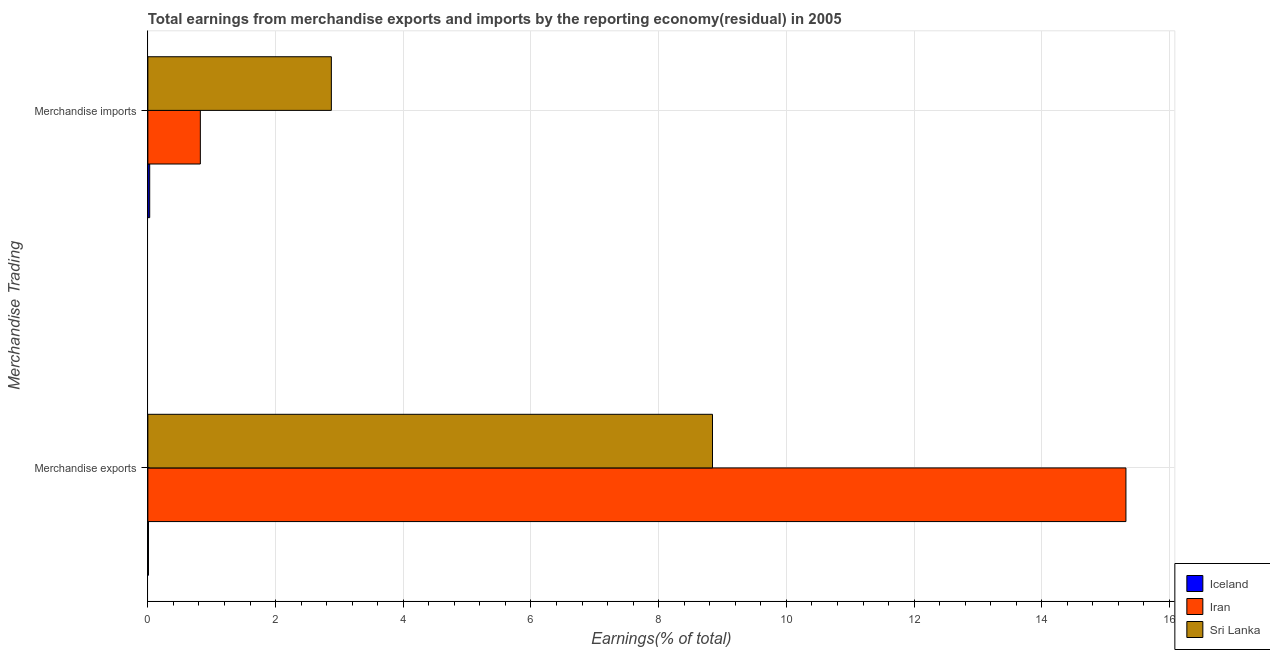How many different coloured bars are there?
Offer a very short reply. 3. How many groups of bars are there?
Your answer should be compact. 2. Are the number of bars on each tick of the Y-axis equal?
Your response must be concise. Yes. What is the earnings from merchandise exports in Iceland?
Offer a very short reply. 0.01. Across all countries, what is the maximum earnings from merchandise exports?
Your answer should be compact. 15.32. Across all countries, what is the minimum earnings from merchandise imports?
Your response must be concise. 0.03. In which country was the earnings from merchandise exports maximum?
Provide a succinct answer. Iran. In which country was the earnings from merchandise imports minimum?
Your response must be concise. Iceland. What is the total earnings from merchandise exports in the graph?
Provide a succinct answer. 24.17. What is the difference between the earnings from merchandise imports in Sri Lanka and that in Iceland?
Your response must be concise. 2.85. What is the difference between the earnings from merchandise imports in Iran and the earnings from merchandise exports in Iceland?
Ensure brevity in your answer.  0.81. What is the average earnings from merchandise exports per country?
Your answer should be very brief. 8.06. What is the difference between the earnings from merchandise imports and earnings from merchandise exports in Sri Lanka?
Offer a very short reply. -5.97. What is the ratio of the earnings from merchandise imports in Iran to that in Iceland?
Offer a very short reply. 28.67. In how many countries, is the earnings from merchandise exports greater than the average earnings from merchandise exports taken over all countries?
Provide a short and direct response. 2. What does the 1st bar from the bottom in Merchandise exports represents?
Keep it short and to the point. Iceland. Are all the bars in the graph horizontal?
Ensure brevity in your answer.  Yes. How many countries are there in the graph?
Offer a terse response. 3. What is the difference between two consecutive major ticks on the X-axis?
Offer a very short reply. 2. Are the values on the major ticks of X-axis written in scientific E-notation?
Your response must be concise. No. Does the graph contain any zero values?
Provide a succinct answer. No. Where does the legend appear in the graph?
Make the answer very short. Bottom right. How many legend labels are there?
Your answer should be compact. 3. What is the title of the graph?
Offer a very short reply. Total earnings from merchandise exports and imports by the reporting economy(residual) in 2005. Does "Latin America(developing only)" appear as one of the legend labels in the graph?
Offer a terse response. No. What is the label or title of the X-axis?
Offer a very short reply. Earnings(% of total). What is the label or title of the Y-axis?
Your answer should be compact. Merchandise Trading. What is the Earnings(% of total) in Iceland in Merchandise exports?
Provide a succinct answer. 0.01. What is the Earnings(% of total) of Iran in Merchandise exports?
Your response must be concise. 15.32. What is the Earnings(% of total) in Sri Lanka in Merchandise exports?
Provide a succinct answer. 8.84. What is the Earnings(% of total) in Iceland in Merchandise imports?
Provide a succinct answer. 0.03. What is the Earnings(% of total) in Iran in Merchandise imports?
Make the answer very short. 0.82. What is the Earnings(% of total) in Sri Lanka in Merchandise imports?
Provide a succinct answer. 2.87. Across all Merchandise Trading, what is the maximum Earnings(% of total) of Iceland?
Provide a short and direct response. 0.03. Across all Merchandise Trading, what is the maximum Earnings(% of total) in Iran?
Offer a terse response. 15.32. Across all Merchandise Trading, what is the maximum Earnings(% of total) of Sri Lanka?
Provide a succinct answer. 8.84. Across all Merchandise Trading, what is the minimum Earnings(% of total) of Iceland?
Ensure brevity in your answer.  0.01. Across all Merchandise Trading, what is the minimum Earnings(% of total) of Iran?
Keep it short and to the point. 0.82. Across all Merchandise Trading, what is the minimum Earnings(% of total) of Sri Lanka?
Your answer should be very brief. 2.87. What is the total Earnings(% of total) in Iceland in the graph?
Provide a short and direct response. 0.04. What is the total Earnings(% of total) of Iran in the graph?
Your answer should be very brief. 16.14. What is the total Earnings(% of total) in Sri Lanka in the graph?
Provide a short and direct response. 11.72. What is the difference between the Earnings(% of total) of Iceland in Merchandise exports and that in Merchandise imports?
Give a very brief answer. -0.02. What is the difference between the Earnings(% of total) of Iran in Merchandise exports and that in Merchandise imports?
Your answer should be compact. 14.5. What is the difference between the Earnings(% of total) in Sri Lanka in Merchandise exports and that in Merchandise imports?
Provide a succinct answer. 5.97. What is the difference between the Earnings(% of total) in Iceland in Merchandise exports and the Earnings(% of total) in Iran in Merchandise imports?
Keep it short and to the point. -0.81. What is the difference between the Earnings(% of total) in Iceland in Merchandise exports and the Earnings(% of total) in Sri Lanka in Merchandise imports?
Make the answer very short. -2.86. What is the difference between the Earnings(% of total) of Iran in Merchandise exports and the Earnings(% of total) of Sri Lanka in Merchandise imports?
Offer a terse response. 12.44. What is the average Earnings(% of total) in Iceland per Merchandise Trading?
Ensure brevity in your answer.  0.02. What is the average Earnings(% of total) in Iran per Merchandise Trading?
Keep it short and to the point. 8.07. What is the average Earnings(% of total) of Sri Lanka per Merchandise Trading?
Provide a succinct answer. 5.86. What is the difference between the Earnings(% of total) in Iceland and Earnings(% of total) in Iran in Merchandise exports?
Your answer should be very brief. -15.31. What is the difference between the Earnings(% of total) of Iceland and Earnings(% of total) of Sri Lanka in Merchandise exports?
Offer a terse response. -8.83. What is the difference between the Earnings(% of total) in Iran and Earnings(% of total) in Sri Lanka in Merchandise exports?
Offer a terse response. 6.47. What is the difference between the Earnings(% of total) of Iceland and Earnings(% of total) of Iran in Merchandise imports?
Your answer should be very brief. -0.79. What is the difference between the Earnings(% of total) of Iceland and Earnings(% of total) of Sri Lanka in Merchandise imports?
Give a very brief answer. -2.85. What is the difference between the Earnings(% of total) in Iran and Earnings(% of total) in Sri Lanka in Merchandise imports?
Offer a terse response. -2.05. What is the ratio of the Earnings(% of total) of Iceland in Merchandise exports to that in Merchandise imports?
Make the answer very short. 0.33. What is the ratio of the Earnings(% of total) of Iran in Merchandise exports to that in Merchandise imports?
Your response must be concise. 18.64. What is the ratio of the Earnings(% of total) in Sri Lanka in Merchandise exports to that in Merchandise imports?
Ensure brevity in your answer.  3.08. What is the difference between the highest and the second highest Earnings(% of total) of Iceland?
Your response must be concise. 0.02. What is the difference between the highest and the second highest Earnings(% of total) of Iran?
Ensure brevity in your answer.  14.5. What is the difference between the highest and the second highest Earnings(% of total) of Sri Lanka?
Your answer should be very brief. 5.97. What is the difference between the highest and the lowest Earnings(% of total) of Iceland?
Provide a succinct answer. 0.02. What is the difference between the highest and the lowest Earnings(% of total) in Iran?
Make the answer very short. 14.5. What is the difference between the highest and the lowest Earnings(% of total) in Sri Lanka?
Provide a short and direct response. 5.97. 